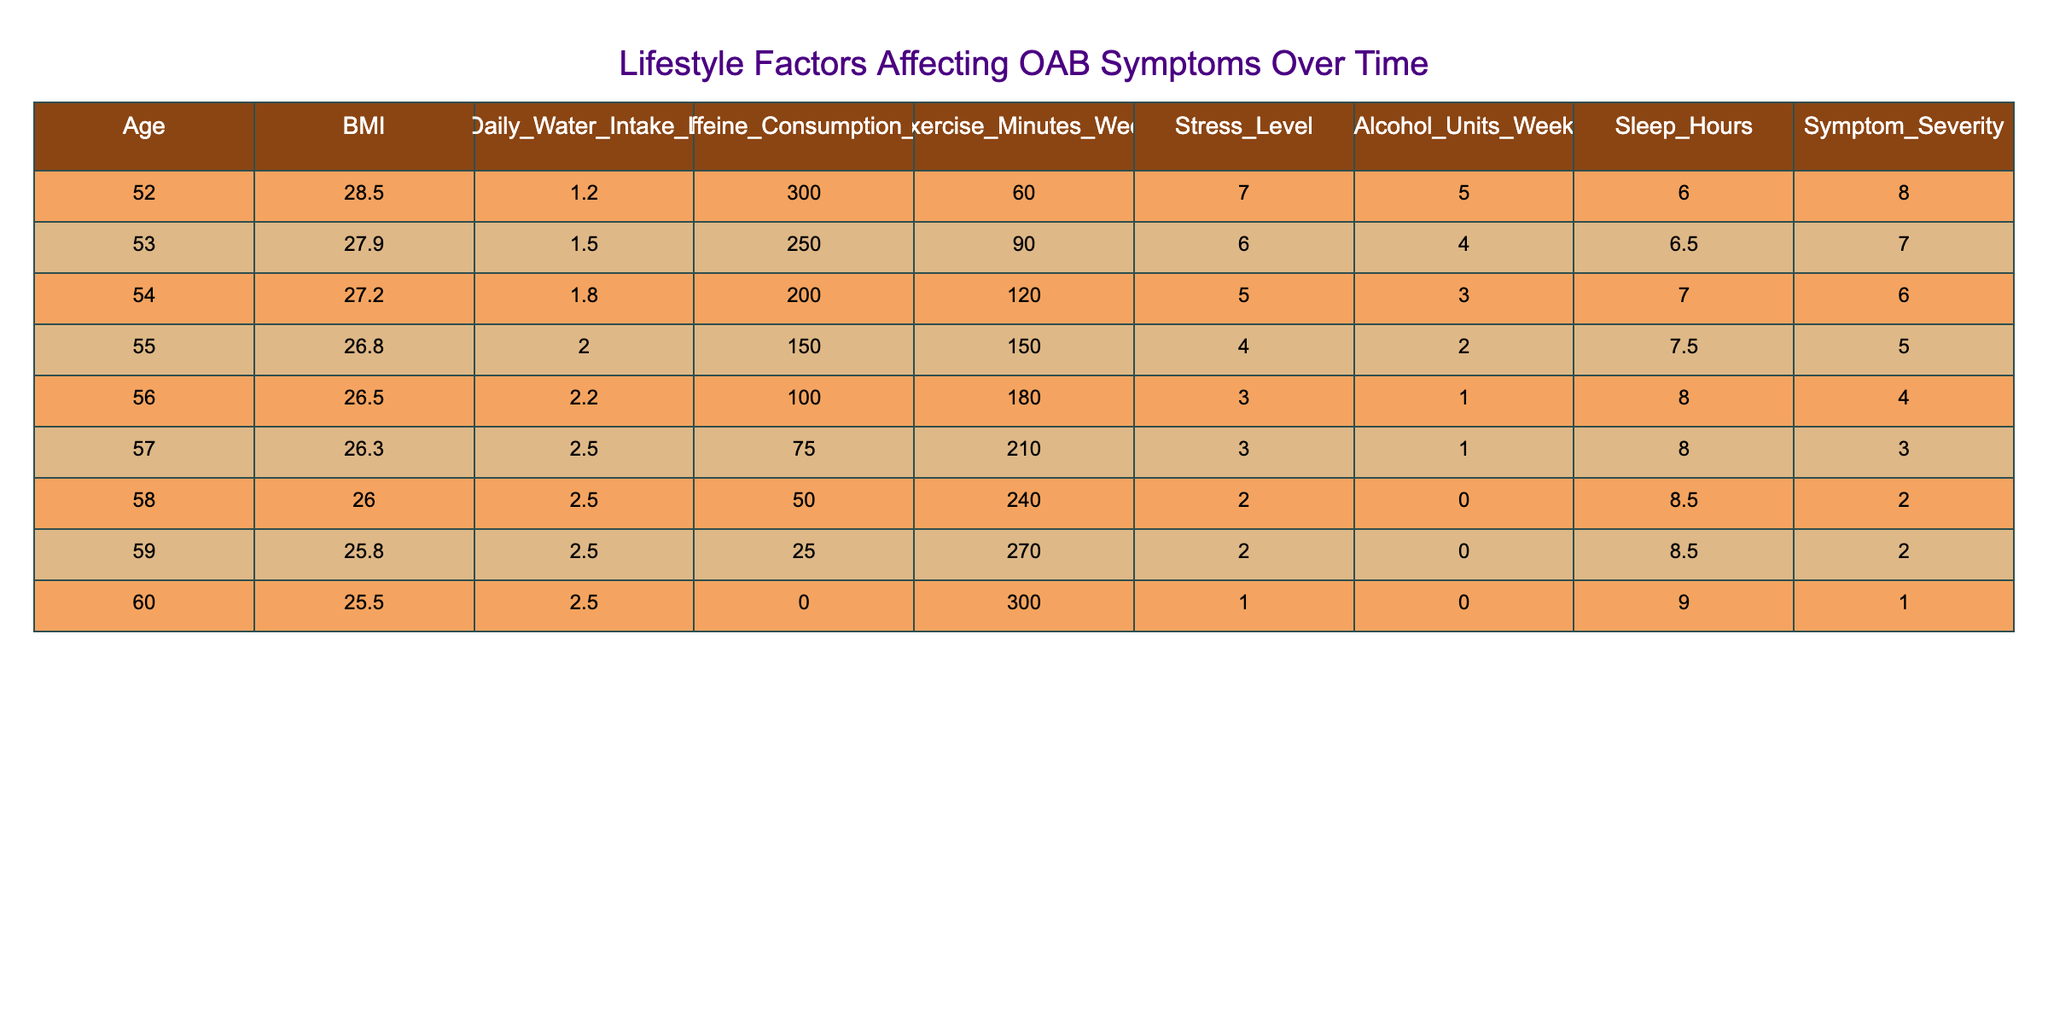What is the symptom severity for the person aged 58? From the table, the entry for age 58 lists the symptom severity as 2.
Answer: 2 How many hours of sleep does the person with a BMI of 28.5 get? The table shows that the person with a BMI of 28.5, who is aged 52, gets 6 hours of sleep.
Answer: 6 What is the average caffeine consumption across all ages? To find the average, add all the caffeine consumption values: (300 + 250 + 200 + 150 + 100 + 75 + 50 + 25 + 0) = 1150, and then divide by the number of entries (9): 1150/9 ≈ 127.78.
Answer: Approximately 127.78 Is the stress level associated with higher symptom severity? The data indicates generally lower symptom severity correlates with lower stress levels, as seen with age 60 (stress level 1, severity 1) and age 52 (stress level 7, severity 8); hence there is a pattern that suggests yes.
Answer: Yes What is the difference in symptom severity between the oldest and youngest individuals in the data? The oldest individual is aged 60 with a severity of 1, and the youngest is aged 52 with a severity of 8. The difference is 8 - 1 = 7.
Answer: 7 What lifestyle factor has the highest negative correlation with symptom severity? Noticing the entries, as daily water intake increases, symptom severity decreases significantly; therefore, daily water intake likely has the highest negative correlation.
Answer: Daily water intake How many exercise minutes does the person experiencing the lowest symptom severity engage in? The individual with the lowest symptom severity, aged 60, engages in 300 minutes of exercise per week.
Answer: 300 What is the median age of individuals in the data? Sorting the ages: 52, 53, 54, 55, 56, 57, 58, 59, 60 shows the middle value (5th and 6th, i.e., 56 and 57) gives a median of (56 + 57)/2 = 56.5.
Answer: 56.5 Does every individual consuming over 200 mg of caffeine have a symptom severity higher than 5? Checking the table, the individual consuming 250 mg has severity 7, and 300 mg has severity 8, so the claim holds true in these instances; thus, the answer is yes.
Answer: Yes If a person increases their daily water intake by 0.5 L, which corresponds to the highest increase in symptom severity? Comparing what we see, the most dramatic decrease in symptom severity occurs with increasing water intake from 1.2 L (severity 8) to 2.5 L (severity 2); thus, severity 8 shows the highest decrease input.
Answer: Severity 8 